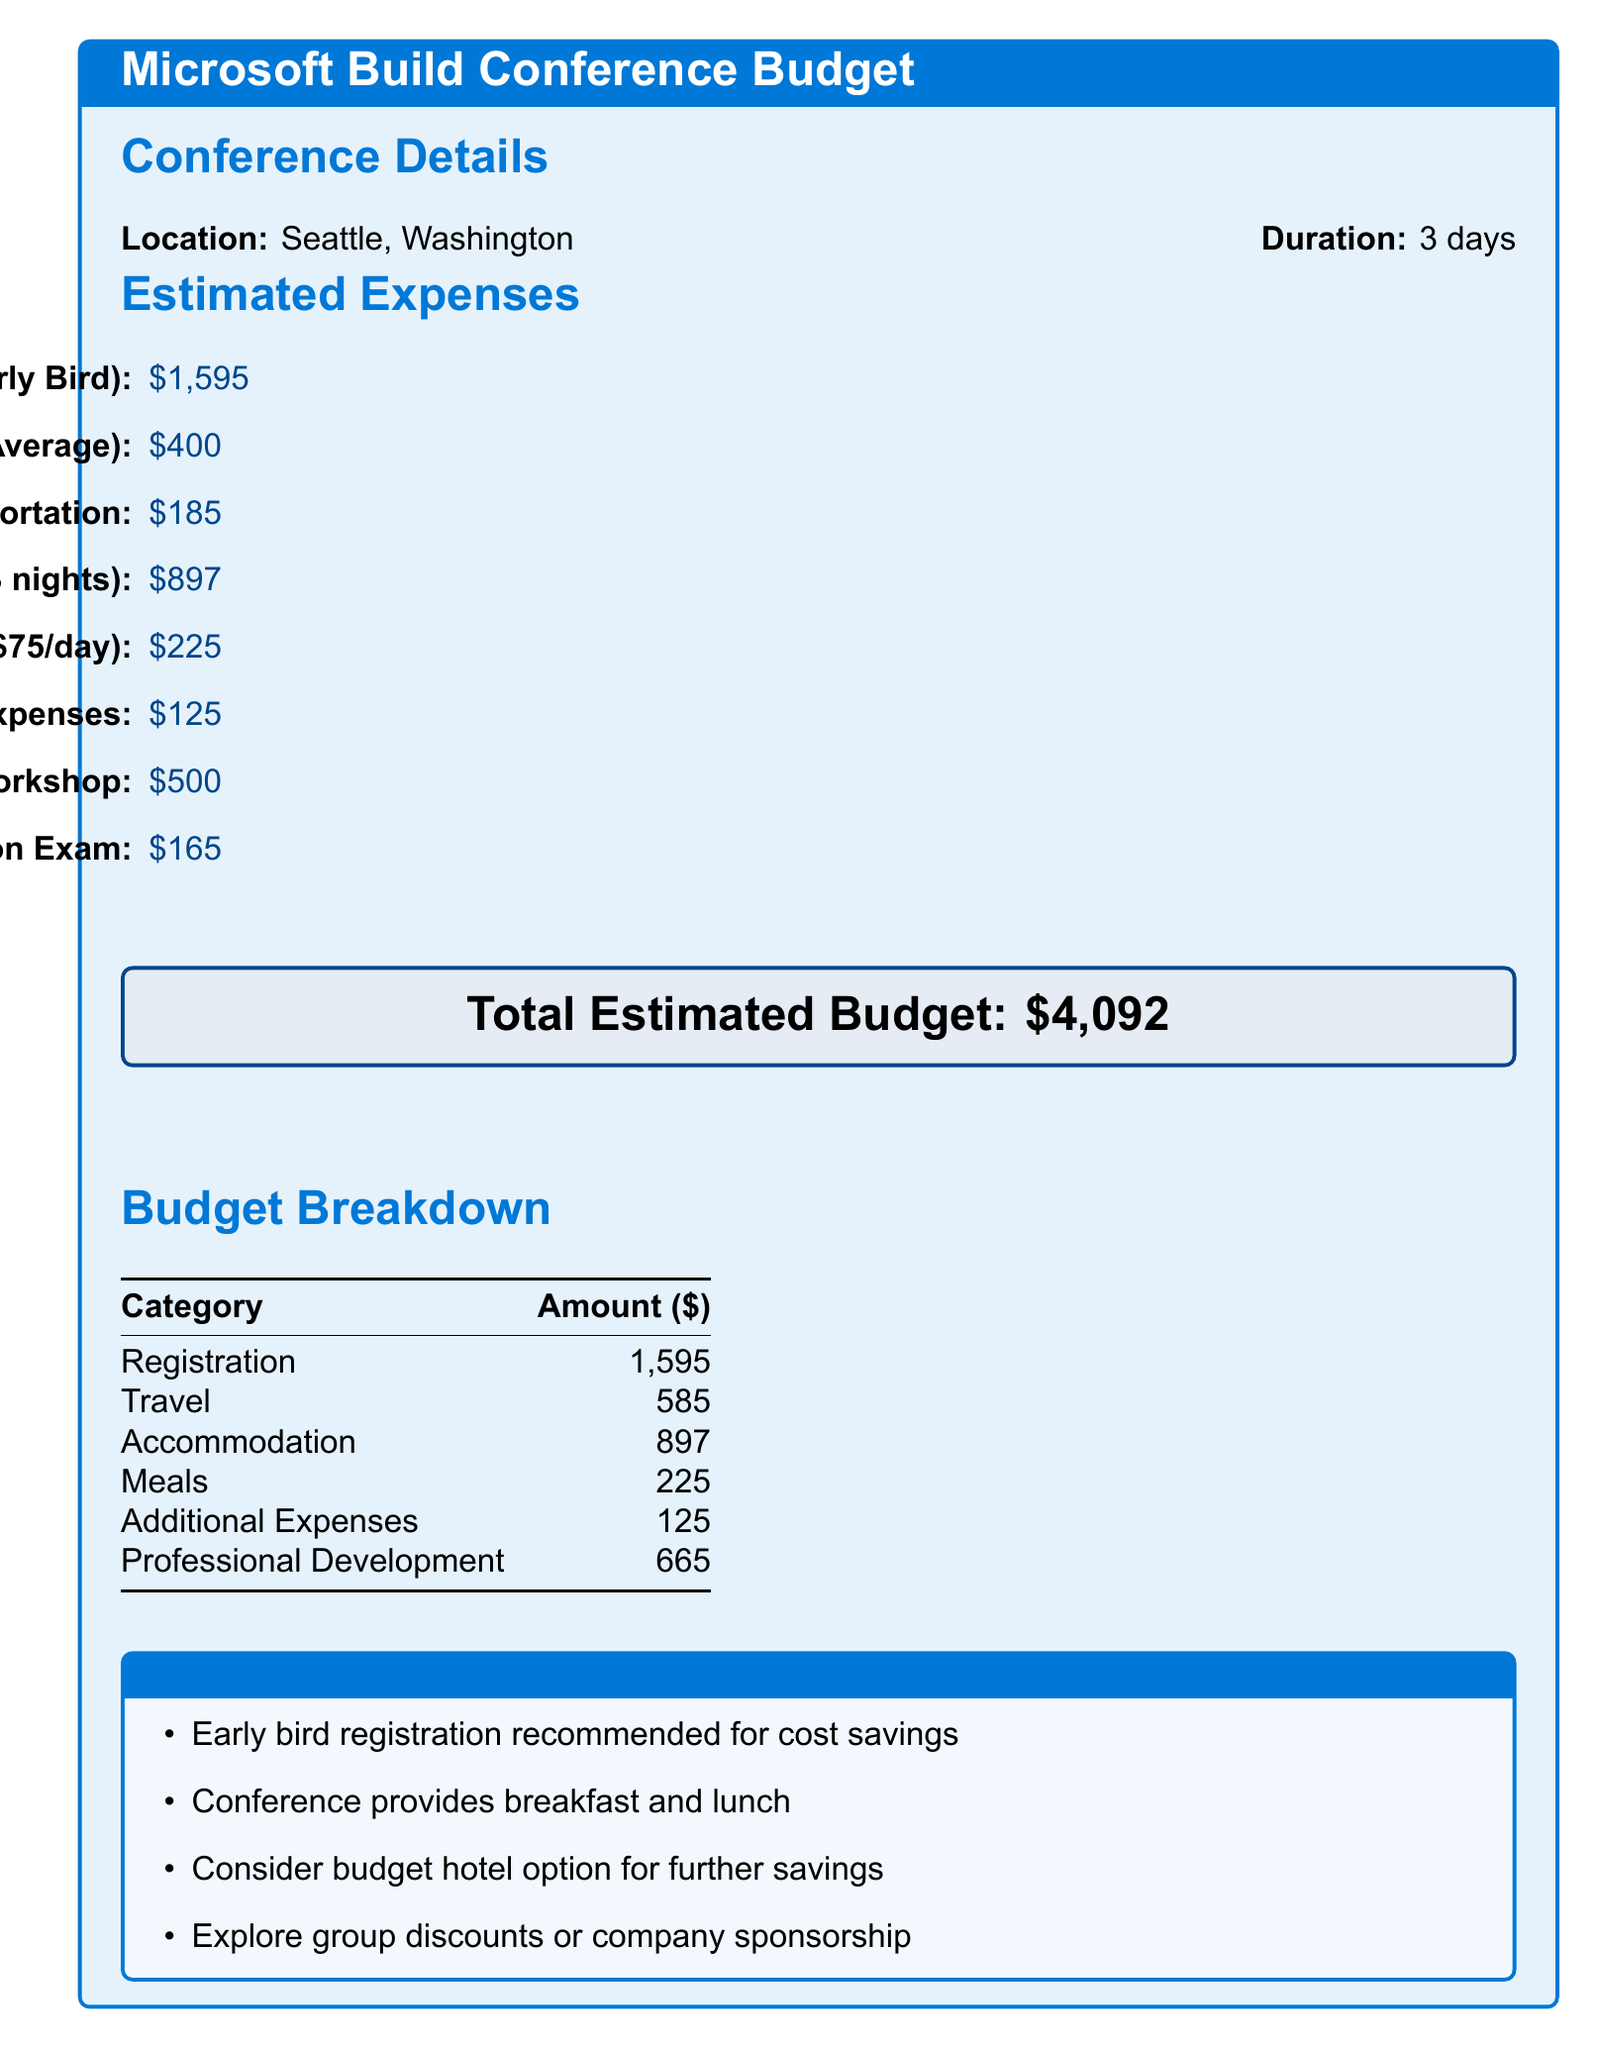What is the location of the conference? The document specifies that the conference takes place in Seattle, Washington.
Answer: Seattle, Washington What is the duration of the conference? The duration of the conference is stated as 3 days.
Answer: 3 days What is the registration cost? The budget item for registration indicates the cost is $1,595.
Answer: $1,595 How much is allocated for meals? The document details that meals will cost $225 for 3 days.
Answer: $225 What is the total estimated budget? The total estimated budget, as highlighted in the document, sums to $4,092.
Answer: $4,092 What is the amount budgeted for local transportation? The budget for local transportation is listed as $185.
Answer: $185 What additional expense is mentioned? The document includes additional expenses totaling $125.
Answer: $125 What is the cost of the post-conference certification exam? The budget specifies that the cost for the certification exam is $165.
Answer: $165 What is the total cost for travel? Travel costs add up to $585, according to the budget breakdown.
Answer: $585 